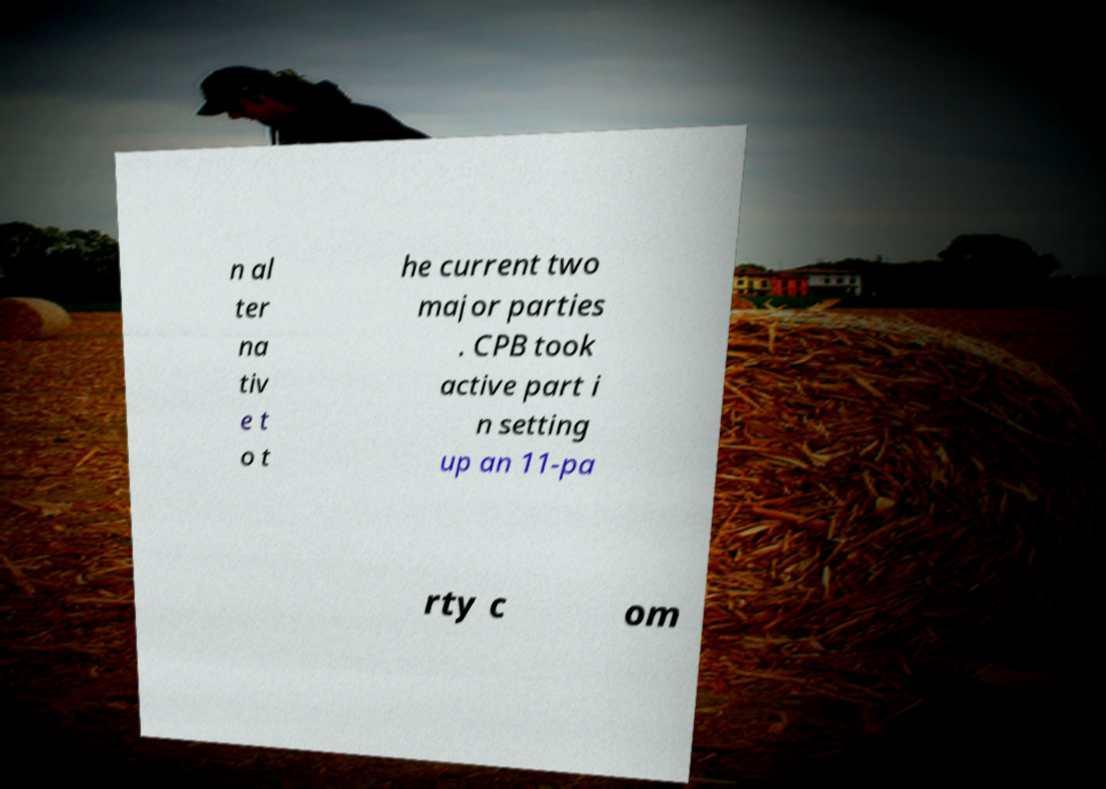There's text embedded in this image that I need extracted. Can you transcribe it verbatim? n al ter na tiv e t o t he current two major parties . CPB took active part i n setting up an 11-pa rty c om 